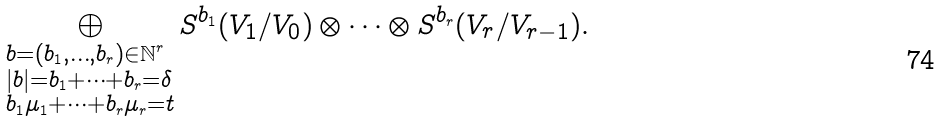Convert formula to latex. <formula><loc_0><loc_0><loc_500><loc_500>\bigoplus _ { \begin{subarray} { c } b = ( b _ { 1 } , \dots , b _ { r } ) \in \mathbb { N } ^ { r } \\ | b | = b _ { 1 } + \cdots + b _ { r } = \delta \\ b _ { 1 } \mu _ { 1 } + \cdots + b _ { r } \mu _ { r } = t \end{subarray} } S ^ { b _ { 1 } } ( V _ { 1 } / V _ { 0 } ) \otimes \cdots \otimes S ^ { b _ { r } } ( V _ { r } / V _ { r - 1 } ) .</formula> 